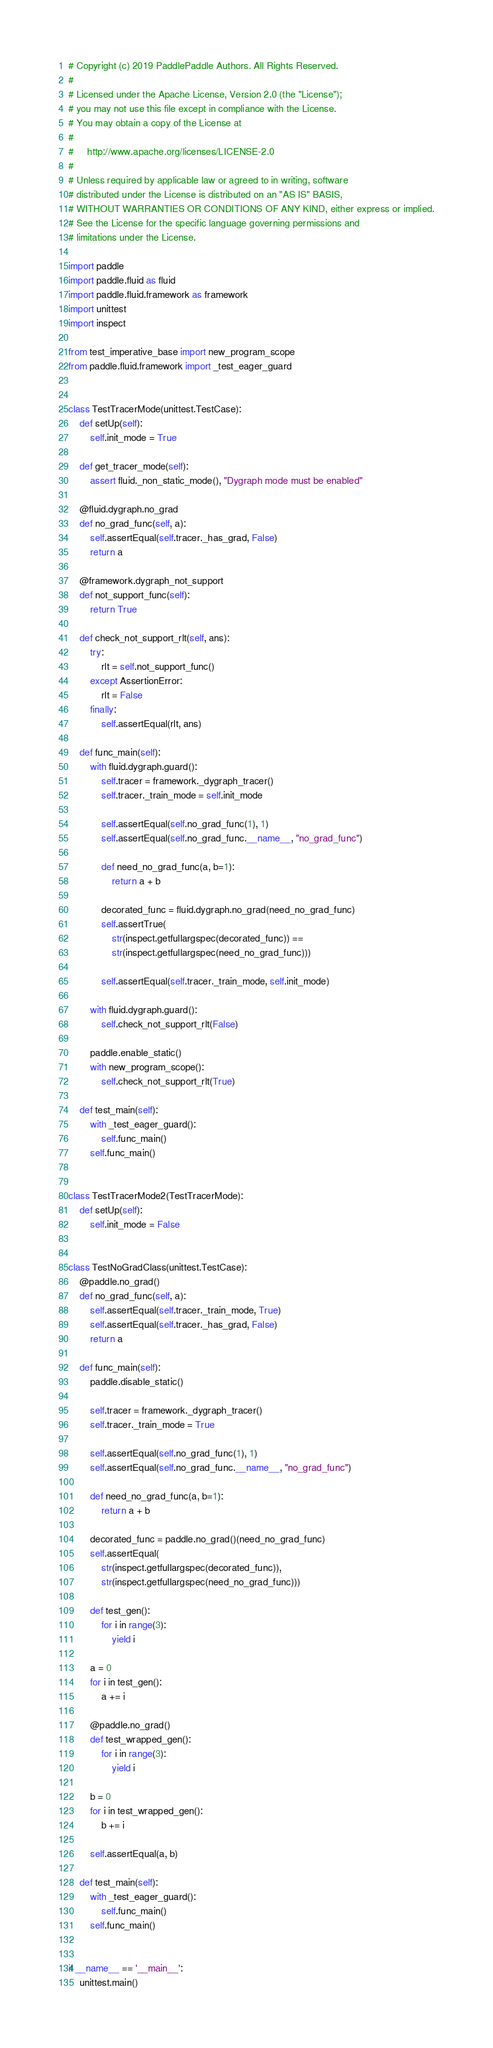Convert code to text. <code><loc_0><loc_0><loc_500><loc_500><_Python_># Copyright (c) 2019 PaddlePaddle Authors. All Rights Reserved.
#
# Licensed under the Apache License, Version 2.0 (the "License");
# you may not use this file except in compliance with the License.
# You may obtain a copy of the License at
#
#     http://www.apache.org/licenses/LICENSE-2.0
#
# Unless required by applicable law or agreed to in writing, software
# distributed under the License is distributed on an "AS IS" BASIS,
# WITHOUT WARRANTIES OR CONDITIONS OF ANY KIND, either express or implied.
# See the License for the specific language governing permissions and
# limitations under the License.

import paddle
import paddle.fluid as fluid
import paddle.fluid.framework as framework
import unittest
import inspect

from test_imperative_base import new_program_scope
from paddle.fluid.framework import _test_eager_guard


class TestTracerMode(unittest.TestCase):
    def setUp(self):
        self.init_mode = True

    def get_tracer_mode(self):
        assert fluid._non_static_mode(), "Dygraph mode must be enabled"

    @fluid.dygraph.no_grad
    def no_grad_func(self, a):
        self.assertEqual(self.tracer._has_grad, False)
        return a

    @framework.dygraph_not_support
    def not_support_func(self):
        return True

    def check_not_support_rlt(self, ans):
        try:
            rlt = self.not_support_func()
        except AssertionError:
            rlt = False
        finally:
            self.assertEqual(rlt, ans)

    def func_main(self):
        with fluid.dygraph.guard():
            self.tracer = framework._dygraph_tracer()
            self.tracer._train_mode = self.init_mode

            self.assertEqual(self.no_grad_func(1), 1)
            self.assertEqual(self.no_grad_func.__name__, "no_grad_func")

            def need_no_grad_func(a, b=1):
                return a + b

            decorated_func = fluid.dygraph.no_grad(need_no_grad_func)
            self.assertTrue(
                str(inspect.getfullargspec(decorated_func)) ==
                str(inspect.getfullargspec(need_no_grad_func)))

            self.assertEqual(self.tracer._train_mode, self.init_mode)

        with fluid.dygraph.guard():
            self.check_not_support_rlt(False)

        paddle.enable_static()
        with new_program_scope():
            self.check_not_support_rlt(True)

    def test_main(self):
        with _test_eager_guard():
            self.func_main()
        self.func_main()


class TestTracerMode2(TestTracerMode):
    def setUp(self):
        self.init_mode = False


class TestNoGradClass(unittest.TestCase):
    @paddle.no_grad()
    def no_grad_func(self, a):
        self.assertEqual(self.tracer._train_mode, True)
        self.assertEqual(self.tracer._has_grad, False)
        return a

    def func_main(self):
        paddle.disable_static()

        self.tracer = framework._dygraph_tracer()
        self.tracer._train_mode = True

        self.assertEqual(self.no_grad_func(1), 1)
        self.assertEqual(self.no_grad_func.__name__, "no_grad_func")

        def need_no_grad_func(a, b=1):
            return a + b

        decorated_func = paddle.no_grad()(need_no_grad_func)
        self.assertEqual(
            str(inspect.getfullargspec(decorated_func)),
            str(inspect.getfullargspec(need_no_grad_func)))

        def test_gen():
            for i in range(3):
                yield i

        a = 0
        for i in test_gen():
            a += i

        @paddle.no_grad()
        def test_wrapped_gen():
            for i in range(3):
                yield i

        b = 0
        for i in test_wrapped_gen():
            b += i

        self.assertEqual(a, b)

    def test_main(self):
        with _test_eager_guard():
            self.func_main()
        self.func_main()


if __name__ == '__main__':
    unittest.main()
</code> 